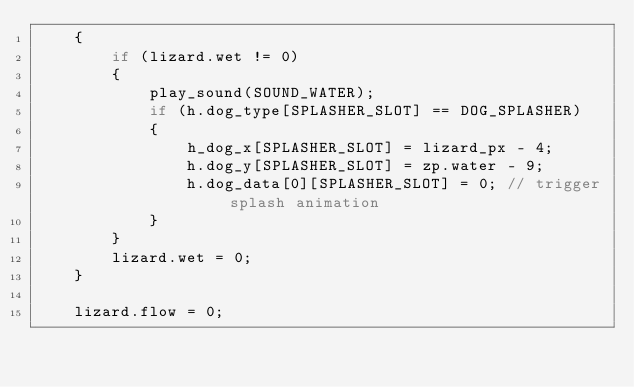<code> <loc_0><loc_0><loc_500><loc_500><_C++_>	{
		if (lizard.wet != 0)
		{
			play_sound(SOUND_WATER);
			if (h.dog_type[SPLASHER_SLOT] == DOG_SPLASHER)
			{
				h_dog_x[SPLASHER_SLOT] = lizard_px - 4;
				h.dog_y[SPLASHER_SLOT] = zp.water - 9;
				h.dog_data[0][SPLASHER_SLOT] = 0; // trigger splash animation
			}
		}
		lizard.wet = 0;
	}

	lizard.flow = 0;</code> 